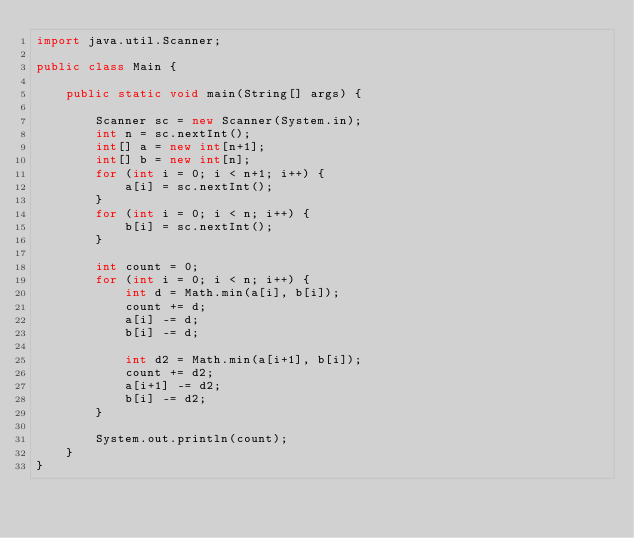<code> <loc_0><loc_0><loc_500><loc_500><_Java_>import java.util.Scanner;

public class Main {

    public static void main(String[] args) {

        Scanner sc = new Scanner(System.in);
        int n = sc.nextInt();
        int[] a = new int[n+1];
        int[] b = new int[n];
        for (int i = 0; i < n+1; i++) {
            a[i] = sc.nextInt();
        }
        for (int i = 0; i < n; i++) {
            b[i] = sc.nextInt();
        }

        int count = 0;
        for (int i = 0; i < n; i++) {
            int d = Math.min(a[i], b[i]);
            count += d;
            a[i] -= d;
            b[i] -= d;

            int d2 = Math.min(a[i+1], b[i]);
            count += d2;
            a[i+1] -= d2;
            b[i] -= d2;
        }

        System.out.println(count);
    }
}</code> 